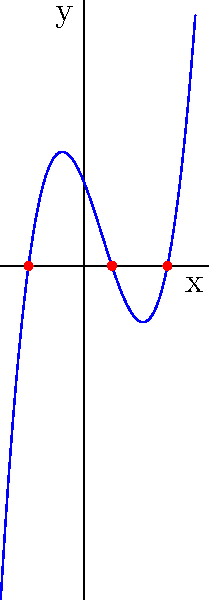As you organize veterans' stories, you come across a graph representing the number of veterans enlisting over time. The graph resembles a cubic function. Given the cubic polynomial graph shown above, what are the roots of the polynomial? Express your answer as a set of x-coordinates. To find the roots of a cubic polynomial from its graph, we need to identify where the curve intersects the x-axis. These points of intersection represent the solutions to the equation $f(x) = 0$.

Step 1: Observe the graph and locate the points where it crosses the x-axis.

Step 2: We can see three distinct points where the curve intersects the x-axis:
1. The leftmost point is at $x = -2$
2. The middle point is at $x = 1$
3. The rightmost point is at $x = 3$

Step 3: These x-coordinates represent the roots of the polynomial.

Step 4: Express the roots as a set of x-coordinates: $\{-2, 1, 3\}$

Note: In the context of veterans enlisting over time, these roots could represent years when the number of enlistments was zero or when there was a significant change in enlistment trends.
Answer: $\{-2, 1, 3\}$ 